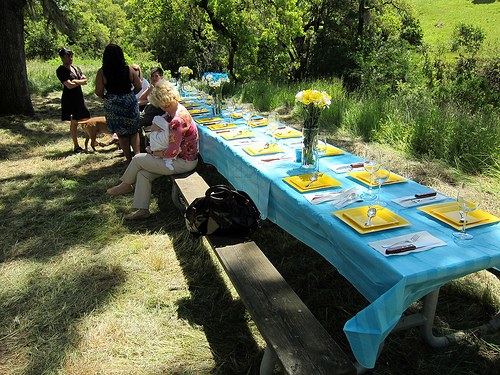<image>
Is the bench behind the table? Yes. From this viewpoint, the bench is positioned behind the table, with the table partially or fully occluding the bench. 